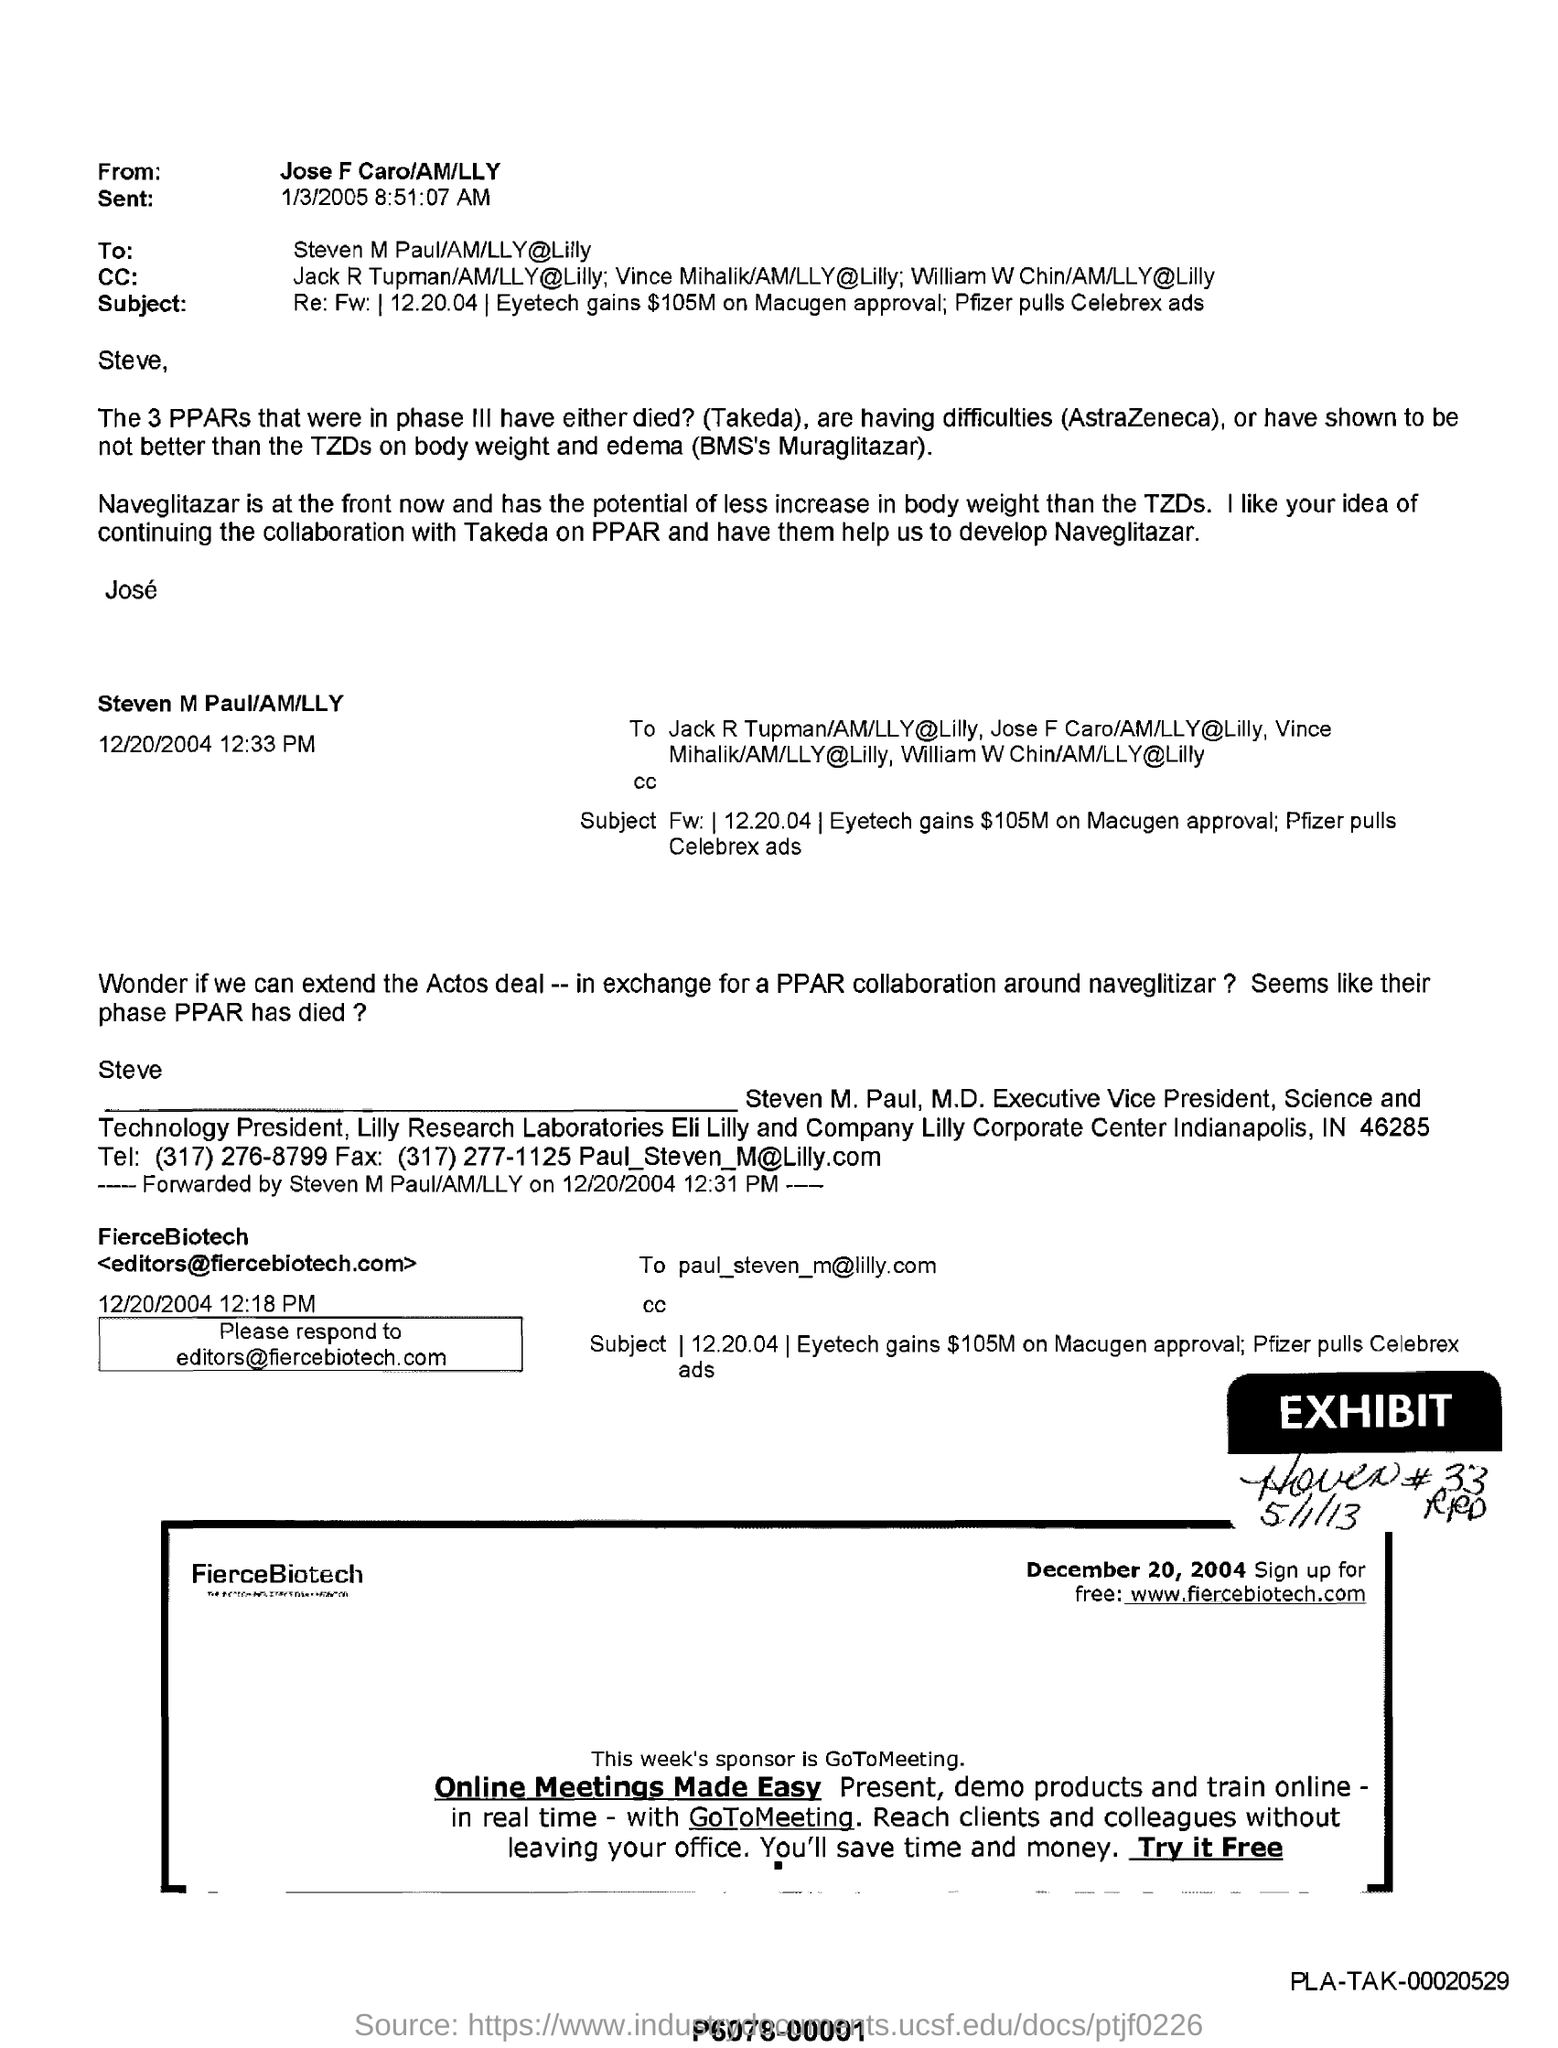Who is the sender of this email
Offer a terse response. Jose f caro. 